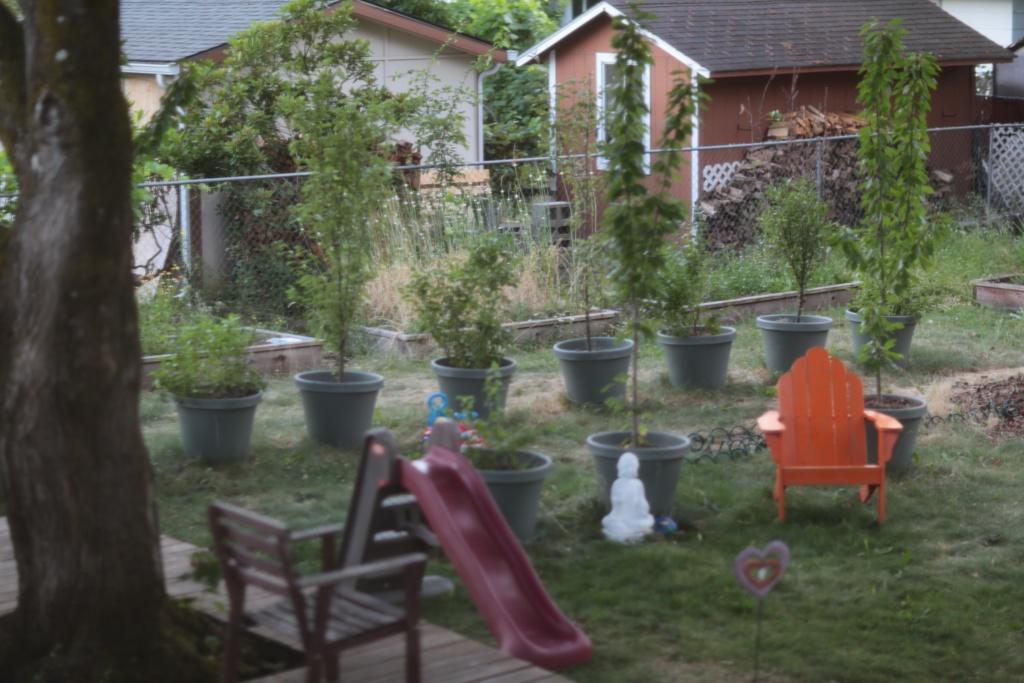How would you summarize this image in a sentence or two? In this image I can see a chair,flower pot and a house. 